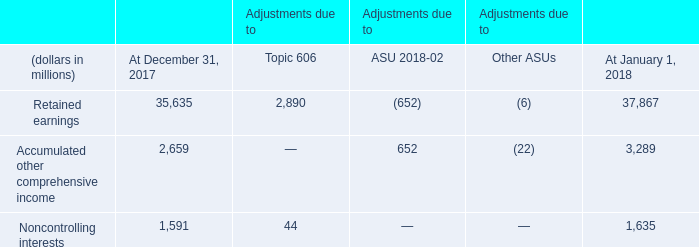Opening Equity Balance Sheet Adjustments from Accounting Standards Adopted in 2018
On January 1, 2018, we adopted Topic 606, ASU 2018-02, Income Statement-Reporting Comprehensive Income and other ASUs. We adopted Topic 606 using the modified retrospective method. We early adopted ASU 2018-02, which allows a reclassification from accumulated other comprehensive income to retained earnings for stranded tax effects resulting from Tax Cuts and Jobs Act (TCJA).
The cumulative after-tax effect of the changes made to our consolidated balance sheet for the adoption of Topic 606, ASU 2018-02 and other ASUs was as follows:
Which Standards were Adopted on January 1, 2018? Topic 606, asu 2018-02, income statement-reporting comprehensive income and other asus. Which method was used for adopting Topic 606? The modified retrospective method. What is the retained earnings as of December 31, 2017?
Answer scale should be: million. 35,635. What is the change in Retained earnings from December 31, 2017 to January 1, 2018?
Answer scale should be: million. 37,867-35,635
Answer: 2232. What is the change in Accumulated other comprehensive income from December 31, 2017 to January 1, 2018?
Answer scale should be: million. 3,289-2,659
Answer: 630. What is the change in Noncontrolling interests from December 31, 2017 to January 1, 2018?
Answer scale should be: million. 1,635-1,591
Answer: 44. 